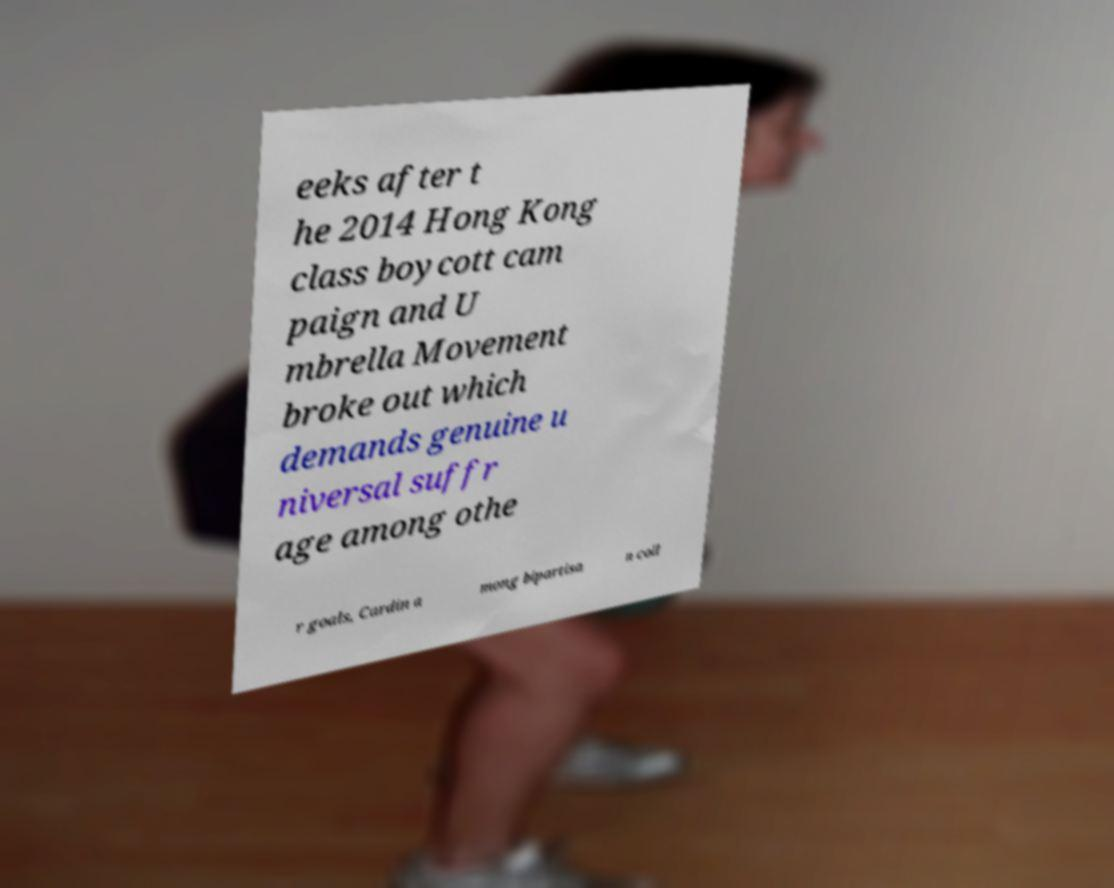There's text embedded in this image that I need extracted. Can you transcribe it verbatim? eeks after t he 2014 Hong Kong class boycott cam paign and U mbrella Movement broke out which demands genuine u niversal suffr age among othe r goals, Cardin a mong bipartisa n coll 